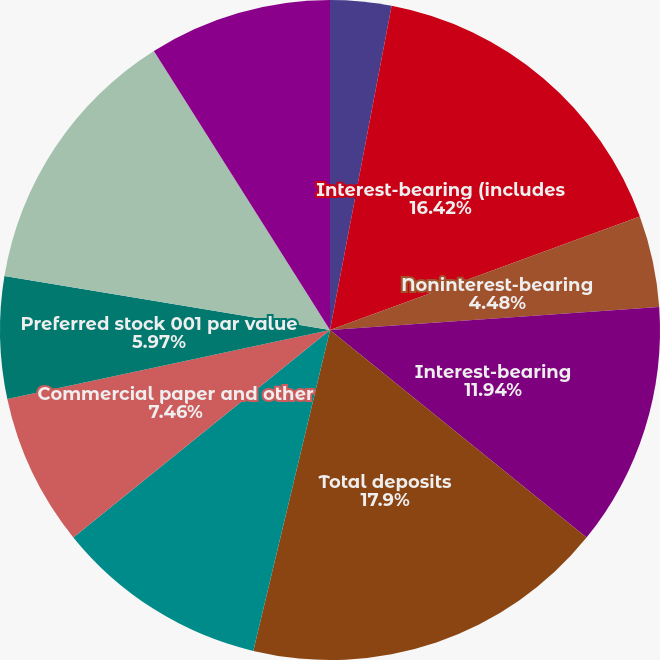Convert chart to OTSL. <chart><loc_0><loc_0><loc_500><loc_500><pie_chart><fcel>(Dollars in millions)<fcel>Interest-bearing (includes<fcel>Noninterest-bearing<fcel>Interest-bearing<fcel>Total deposits<fcel>Derivative liabilities<fcel>Commercial paper and other<fcel>Preferred stock 001 par value<fcel>Common stock and additional<fcel>Retained earnings<nl><fcel>2.99%<fcel>16.42%<fcel>4.48%<fcel>11.94%<fcel>17.91%<fcel>10.45%<fcel>7.46%<fcel>5.97%<fcel>13.43%<fcel>8.96%<nl></chart> 